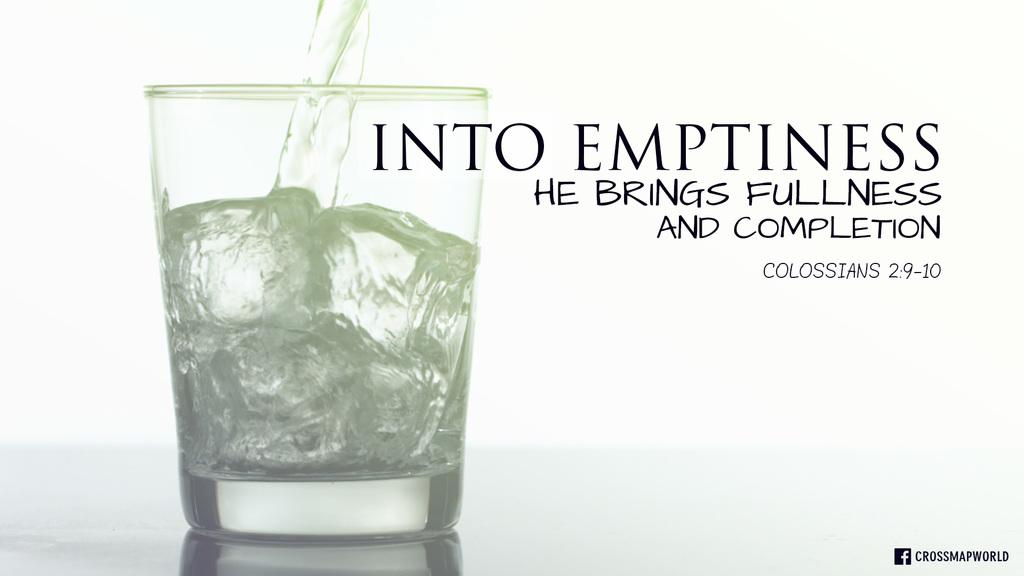Provide a one-sentence caption for the provided image. Ad for alcohol that talks about Bringing fullness and competion. 